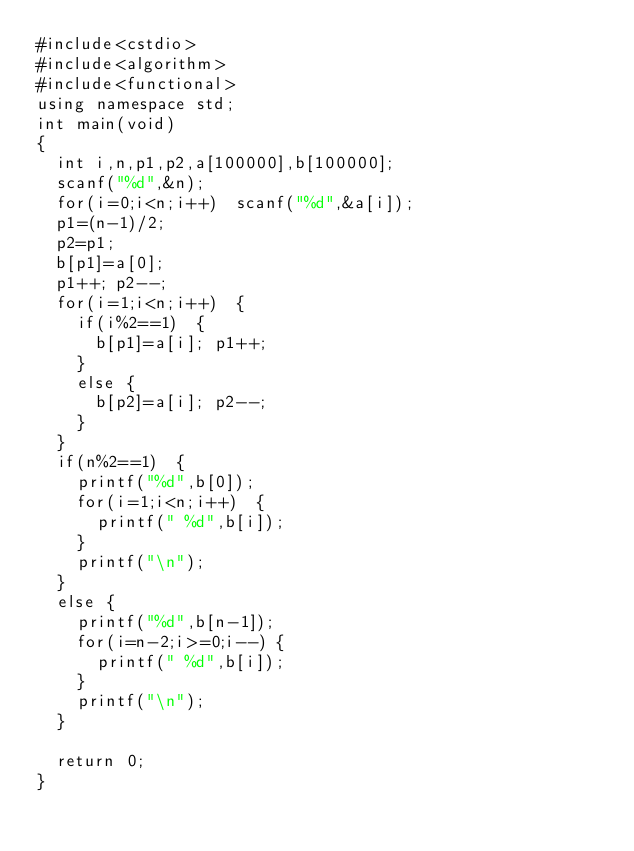Convert code to text. <code><loc_0><loc_0><loc_500><loc_500><_C++_>#include<cstdio>
#include<algorithm>
#include<functional>
using namespace std;
int main(void)
{
	int i,n,p1,p2,a[100000],b[100000];
	scanf("%d",&n);
	for(i=0;i<n;i++)	scanf("%d",&a[i]);
	p1=(n-1)/2;
	p2=p1;
	b[p1]=a[0];
	p1++;	p2--;
	for(i=1;i<n;i++)	{
		if(i%2==1)	{
			b[p1]=a[i];	p1++;
		}
		else {
			b[p2]=a[i];	p2--;
		}
	}
	if(n%2==1)	{
		printf("%d",b[0]);
		for(i=1;i<n;i++)	{
			printf(" %d",b[i]);
		}
		printf("\n");
	}
	else {
		printf("%d",b[n-1]);
		for(i=n-2;i>=0;i--)	{
			printf(" %d",b[i]);
		}
		printf("\n");
	}
	
	return 0;
}</code> 